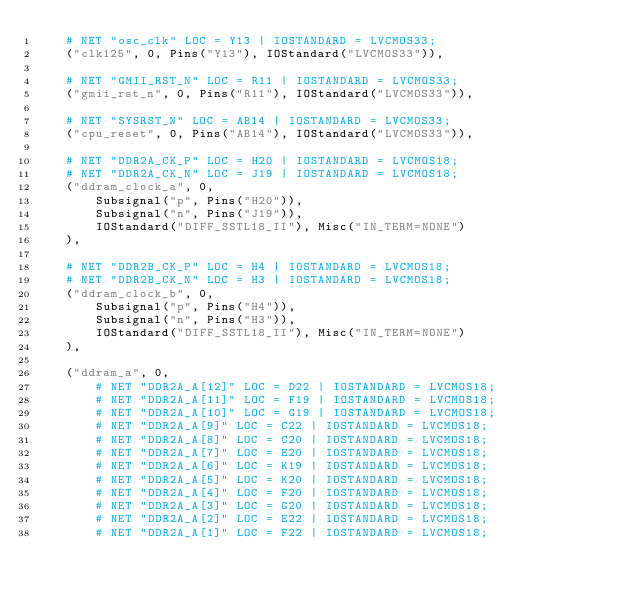Convert code to text. <code><loc_0><loc_0><loc_500><loc_500><_Python_>    # NET "osc_clk" LOC = Y13 | IOSTANDARD = LVCMOS33;
    ("clk125", 0, Pins("Y13"), IOStandard("LVCMOS33")),

    # NET "GMII_RST_N" LOC = R11 | IOSTANDARD = LVCMOS33;
    ("gmii_rst_n", 0, Pins("R11"), IOStandard("LVCMOS33")),

    # NET "SYSRST_N" LOC = AB14 | IOSTANDARD = LVCMOS33;
    ("cpu_reset", 0, Pins("AB14"), IOStandard("LVCMOS33")),

    # NET "DDR2A_CK_P" LOC = H20 | IOSTANDARD = LVCMOS18;
    # NET "DDR2A_CK_N" LOC = J19 | IOSTANDARD = LVCMOS18;
    ("ddram_clock_a", 0,
        Subsignal("p", Pins("H20")),
        Subsignal("n", Pins("J19")),
        IOStandard("DIFF_SSTL18_II"), Misc("IN_TERM=NONE")
    ),

    # NET "DDR2B_CK_P" LOC = H4 | IOSTANDARD = LVCMOS18;
    # NET "DDR2B_CK_N" LOC = H3 | IOSTANDARD = LVCMOS18;
    ("ddram_clock_b", 0,
        Subsignal("p", Pins("H4")),
        Subsignal("n", Pins("H3")),
        IOStandard("DIFF_SSTL18_II"), Misc("IN_TERM=NONE")
    ),

    ("ddram_a", 0,
        # NET "DDR2A_A[12]" LOC = D22 | IOSTANDARD = LVCMOS18;
        # NET "DDR2A_A[11]" LOC = F19 | IOSTANDARD = LVCMOS18;
        # NET "DDR2A_A[10]" LOC = G19 | IOSTANDARD = LVCMOS18;
        # NET "DDR2A_A[9]" LOC = C22 | IOSTANDARD = LVCMOS18;
        # NET "DDR2A_A[8]" LOC = C20 | IOSTANDARD = LVCMOS18;
        # NET "DDR2A_A[7]" LOC = E20 | IOSTANDARD = LVCMOS18;
        # NET "DDR2A_A[6]" LOC = K19 | IOSTANDARD = LVCMOS18;
        # NET "DDR2A_A[5]" LOC = K20 | IOSTANDARD = LVCMOS18;
        # NET "DDR2A_A[4]" LOC = F20 | IOSTANDARD = LVCMOS18;
        # NET "DDR2A_A[3]" LOC = G20 | IOSTANDARD = LVCMOS18;
        # NET "DDR2A_A[2]" LOC = E22 | IOSTANDARD = LVCMOS18;
        # NET "DDR2A_A[1]" LOC = F22 | IOSTANDARD = LVCMOS18;</code> 